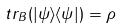<formula> <loc_0><loc_0><loc_500><loc_500>t r _ { B } ( | \psi \rangle \langle \psi | ) = \rho</formula> 